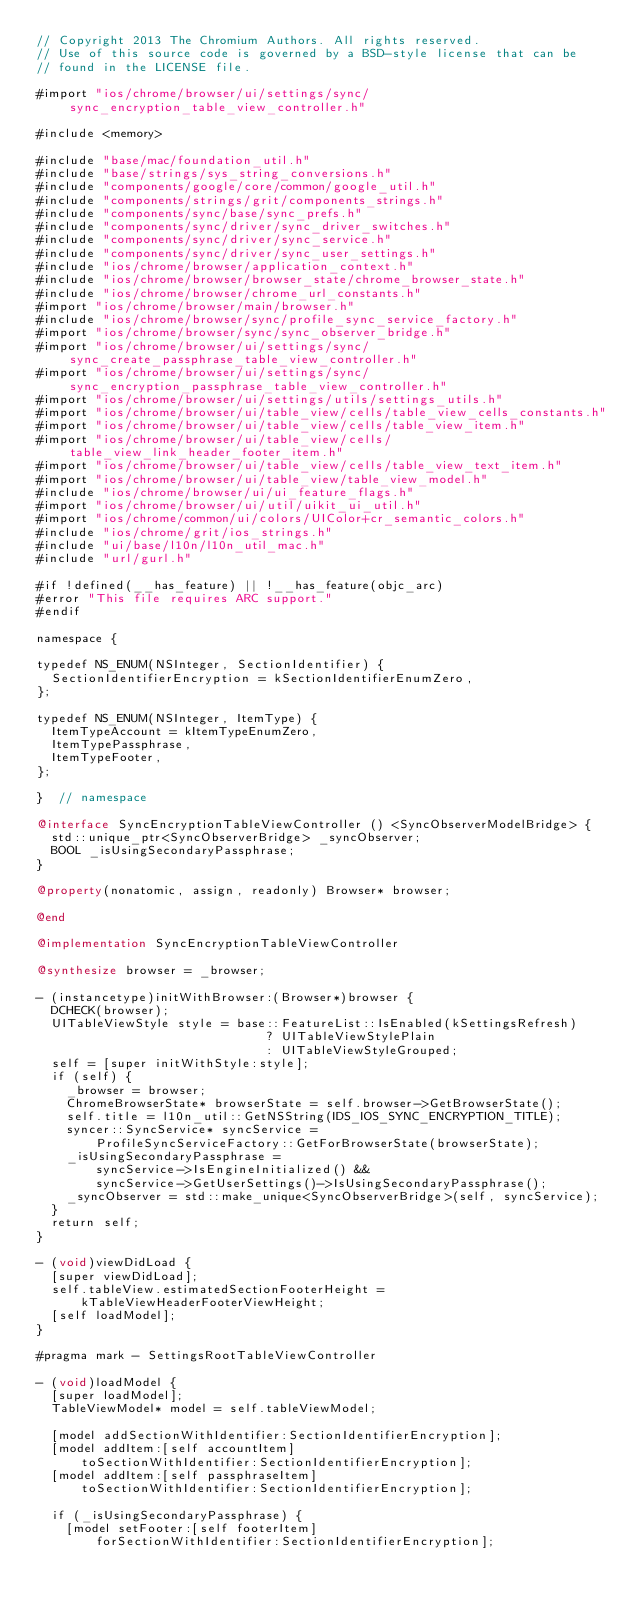Convert code to text. <code><loc_0><loc_0><loc_500><loc_500><_ObjectiveC_>// Copyright 2013 The Chromium Authors. All rights reserved.
// Use of this source code is governed by a BSD-style license that can be
// found in the LICENSE file.

#import "ios/chrome/browser/ui/settings/sync/sync_encryption_table_view_controller.h"

#include <memory>

#include "base/mac/foundation_util.h"
#include "base/strings/sys_string_conversions.h"
#include "components/google/core/common/google_util.h"
#include "components/strings/grit/components_strings.h"
#include "components/sync/base/sync_prefs.h"
#include "components/sync/driver/sync_driver_switches.h"
#include "components/sync/driver/sync_service.h"
#include "components/sync/driver/sync_user_settings.h"
#include "ios/chrome/browser/application_context.h"
#include "ios/chrome/browser/browser_state/chrome_browser_state.h"
#include "ios/chrome/browser/chrome_url_constants.h"
#import "ios/chrome/browser/main/browser.h"
#include "ios/chrome/browser/sync/profile_sync_service_factory.h"
#import "ios/chrome/browser/sync/sync_observer_bridge.h"
#import "ios/chrome/browser/ui/settings/sync/sync_create_passphrase_table_view_controller.h"
#import "ios/chrome/browser/ui/settings/sync/sync_encryption_passphrase_table_view_controller.h"
#import "ios/chrome/browser/ui/settings/utils/settings_utils.h"
#import "ios/chrome/browser/ui/table_view/cells/table_view_cells_constants.h"
#import "ios/chrome/browser/ui/table_view/cells/table_view_item.h"
#import "ios/chrome/browser/ui/table_view/cells/table_view_link_header_footer_item.h"
#import "ios/chrome/browser/ui/table_view/cells/table_view_text_item.h"
#import "ios/chrome/browser/ui/table_view/table_view_model.h"
#include "ios/chrome/browser/ui/ui_feature_flags.h"
#import "ios/chrome/browser/ui/util/uikit_ui_util.h"
#import "ios/chrome/common/ui/colors/UIColor+cr_semantic_colors.h"
#include "ios/chrome/grit/ios_strings.h"
#include "ui/base/l10n/l10n_util_mac.h"
#include "url/gurl.h"

#if !defined(__has_feature) || !__has_feature(objc_arc)
#error "This file requires ARC support."
#endif

namespace {

typedef NS_ENUM(NSInteger, SectionIdentifier) {
  SectionIdentifierEncryption = kSectionIdentifierEnumZero,
};

typedef NS_ENUM(NSInteger, ItemType) {
  ItemTypeAccount = kItemTypeEnumZero,
  ItemTypePassphrase,
  ItemTypeFooter,
};

}  // namespace

@interface SyncEncryptionTableViewController () <SyncObserverModelBridge> {
  std::unique_ptr<SyncObserverBridge> _syncObserver;
  BOOL _isUsingSecondaryPassphrase;
}

@property(nonatomic, assign, readonly) Browser* browser;

@end

@implementation SyncEncryptionTableViewController

@synthesize browser = _browser;

- (instancetype)initWithBrowser:(Browser*)browser {
  DCHECK(browser);
  UITableViewStyle style = base::FeatureList::IsEnabled(kSettingsRefresh)
                               ? UITableViewStylePlain
                               : UITableViewStyleGrouped;
  self = [super initWithStyle:style];
  if (self) {
    _browser = browser;
    ChromeBrowserState* browserState = self.browser->GetBrowserState();
    self.title = l10n_util::GetNSString(IDS_IOS_SYNC_ENCRYPTION_TITLE);
    syncer::SyncService* syncService =
        ProfileSyncServiceFactory::GetForBrowserState(browserState);
    _isUsingSecondaryPassphrase =
        syncService->IsEngineInitialized() &&
        syncService->GetUserSettings()->IsUsingSecondaryPassphrase();
    _syncObserver = std::make_unique<SyncObserverBridge>(self, syncService);
  }
  return self;
}

- (void)viewDidLoad {
  [super viewDidLoad];
  self.tableView.estimatedSectionFooterHeight =
      kTableViewHeaderFooterViewHeight;
  [self loadModel];
}

#pragma mark - SettingsRootTableViewController

- (void)loadModel {
  [super loadModel];
  TableViewModel* model = self.tableViewModel;

  [model addSectionWithIdentifier:SectionIdentifierEncryption];
  [model addItem:[self accountItem]
      toSectionWithIdentifier:SectionIdentifierEncryption];
  [model addItem:[self passphraseItem]
      toSectionWithIdentifier:SectionIdentifierEncryption];

  if (_isUsingSecondaryPassphrase) {
    [model setFooter:[self footerItem]
        forSectionWithIdentifier:SectionIdentifierEncryption];</code> 